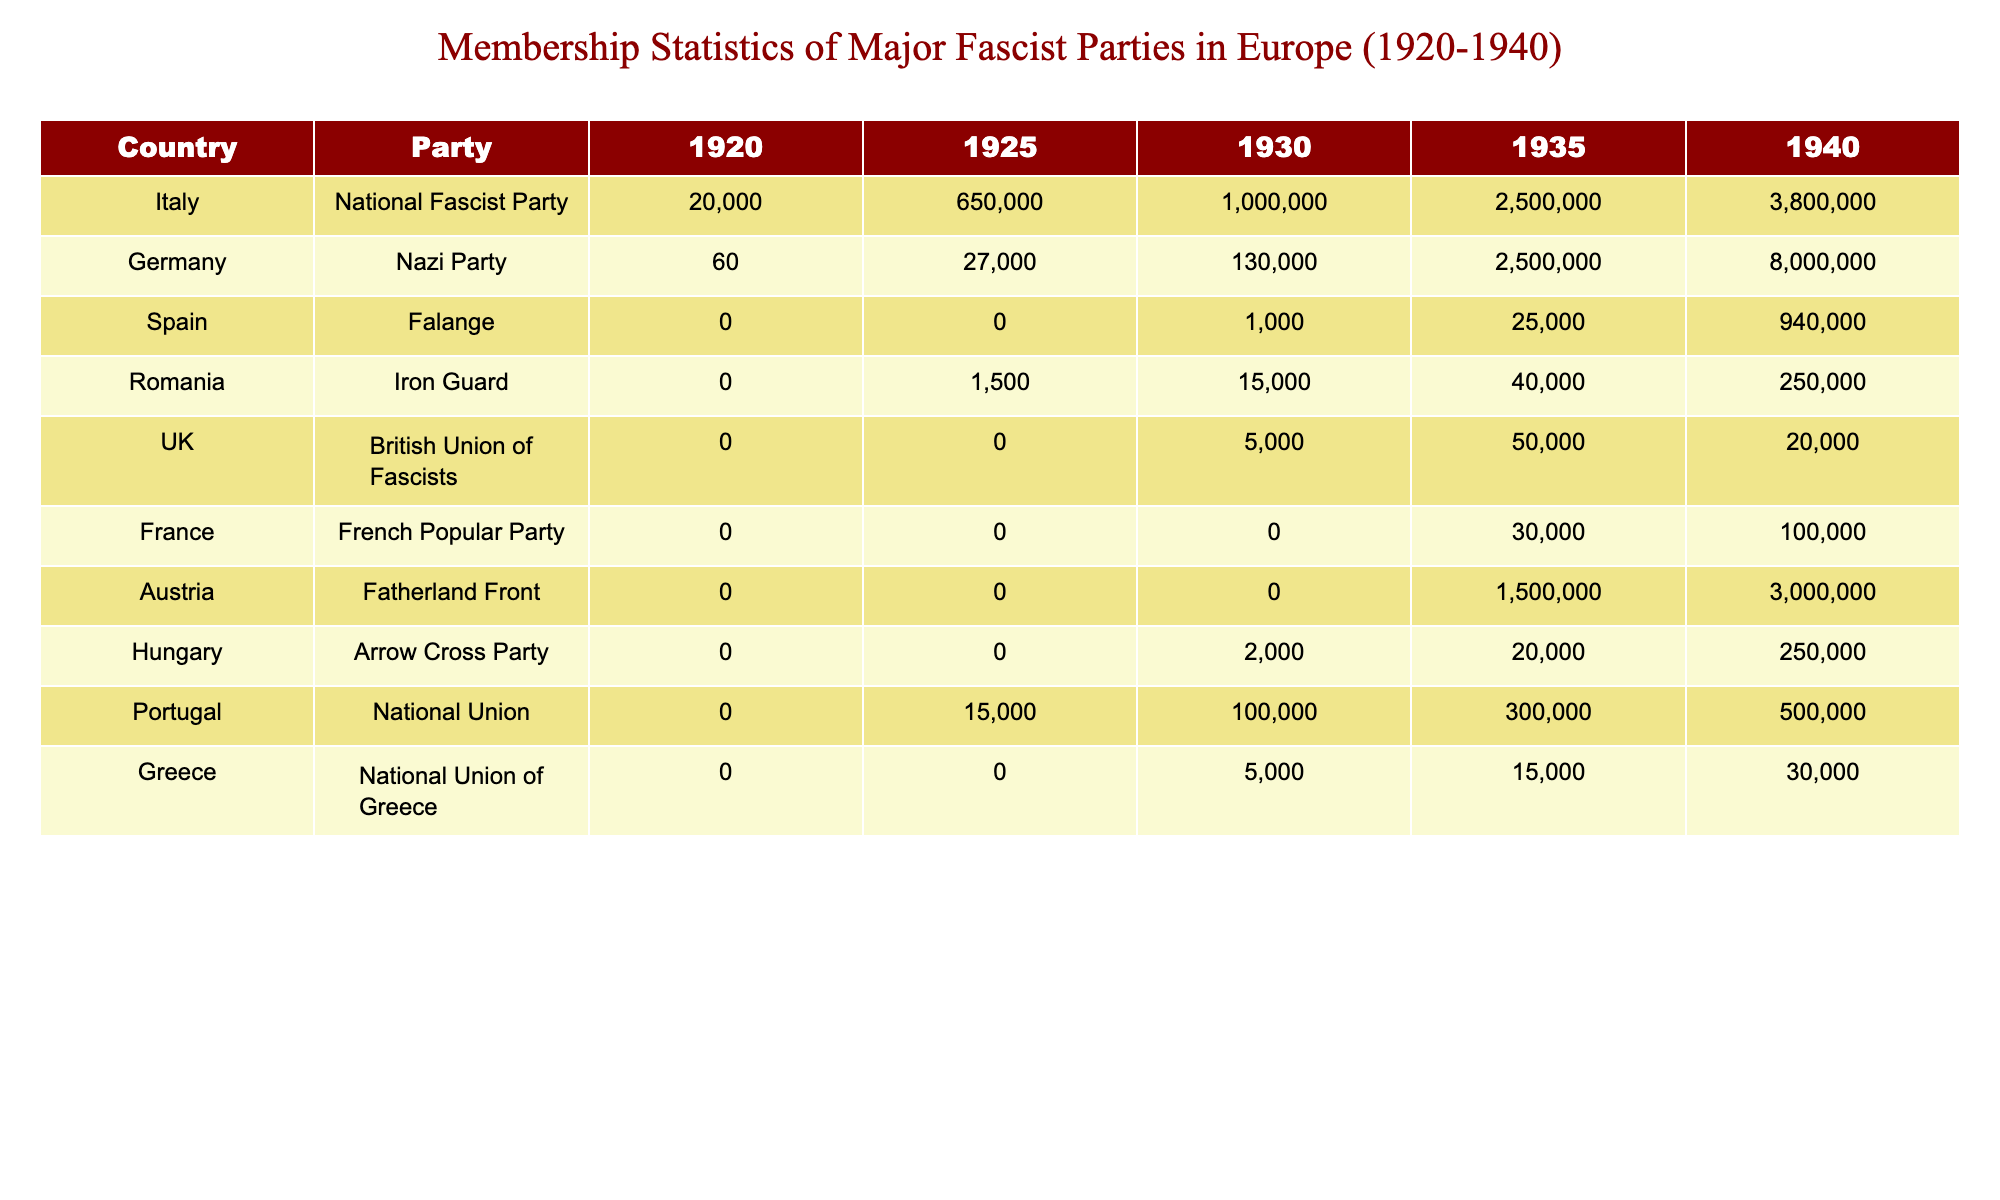What was the membership of the Nazi Party in 1935? The table shows that the membership of the Nazi Party in 1935 was 2,500,000.
Answer: 2,500,000 Which country had the highest membership in 1940? By examining the last column for 1940, Italy's National Fascist Party had the highest membership of 3,800,000.
Answer: Italy How many members did the Falange have in 1930? The table indicates that the Falange had 1,000 members in 1930.
Answer: 1,000 What was the total membership of the major fascist parties in Spain by 1940? The Falange had 940,000 members in 1940, and there were no other major fascist parties listed for Spain; therefore, the total is 940,000.
Answer: 940,000 Did any party in the UK have a membership over 10,000 in 1935? According to the table, the British Union of Fascists had only 50,000 members in 1935, indicating that there was indeed a party above that threshold.
Answer: Yes Which party in Romania saw the most significant growth in membership from 1925 to 1940? The Iron Guard's membership grew from 1,500 in 1925 to 250,000 in 1940, with a difference of 248,500. This is the most significant growth among Romanian parties.
Answer: Iron Guard What is the average membership across all parties in 1940? Summing all party memberships for 1940: 3,800,000 (Italy) + 8,000,000 (Germany) + 940,000 (Spain) + 250,000 (Romania) + 20,000 (UK) + 100,000 (France) + 3,000,000 (Austria) + 250,000 (Hungary) + 500,000 (Portugal) + 30,000 (Greece) = 17,100,000. There are ten parties, so the average is 17,100,000 / 10 = 1,710,000.
Answer: 1,710,000 Which two countries had parties with zero members in 1920? The table indicates that both Spain and the UK had parties with zero membership in 1920.
Answer: Spain and UK Was there a rise in membership for the Fatherland Front from 1930 to 1935? The Fatherland Front had zero members in 1930 and 1,500 in 1935, indicating an increase in membership during that period.
Answer: Yes What percentage of the Nazi Party's 1940 membership does the Iron Guard's 1940 membership represent? The Nazi Party had 8,000,000 members, and the Iron Guard had 250,000. The percentage is (250,000 / 8,000,000) * 100 = 3.125%.
Answer: 3.125% 